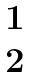<formula> <loc_0><loc_0><loc_500><loc_500>\begin{matrix} \ 1 \ \\ 2 \end{matrix}</formula> 